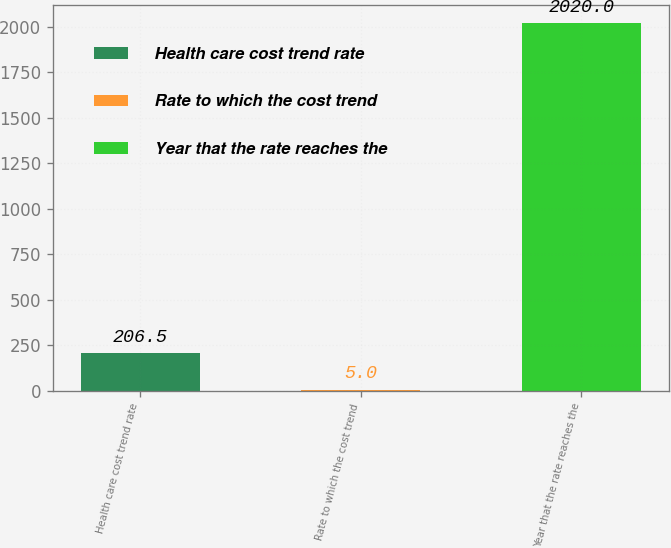<chart> <loc_0><loc_0><loc_500><loc_500><bar_chart><fcel>Health care cost trend rate<fcel>Rate to which the cost trend<fcel>Year that the rate reaches the<nl><fcel>206.5<fcel>5<fcel>2020<nl></chart> 